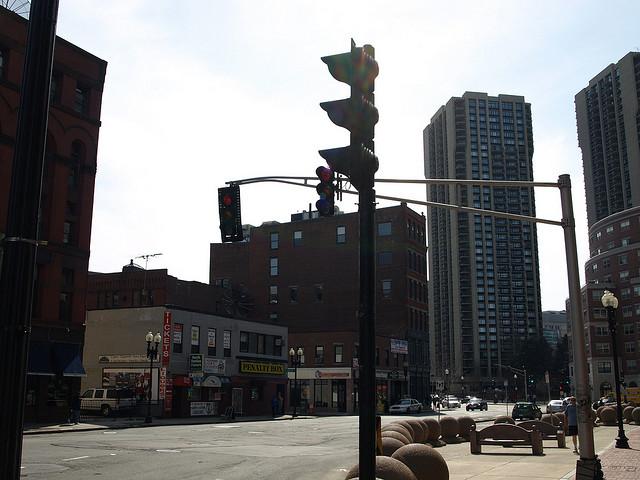Is this a busy intersection?
Short answer required. No. Why are there two lights?
Short answer required. 2 lanes. How many levels does the building on the left have?
Quick response, please. 5. Does the weather appear cold?
Answer briefly. No. 